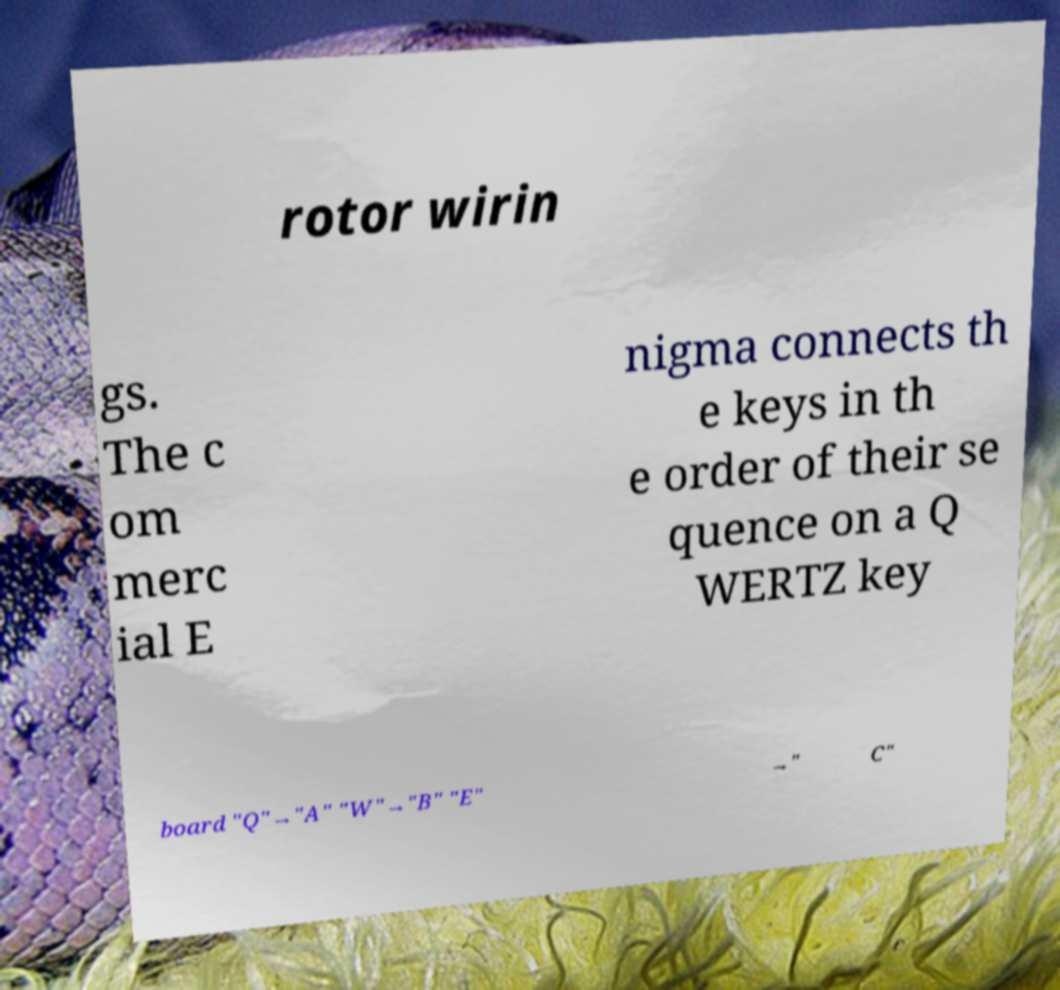Please read and relay the text visible in this image. What does it say? rotor wirin gs. The c om merc ial E nigma connects th e keys in th e order of their se quence on a Q WERTZ key board "Q"→"A" "W"→"B" "E" →" C" 